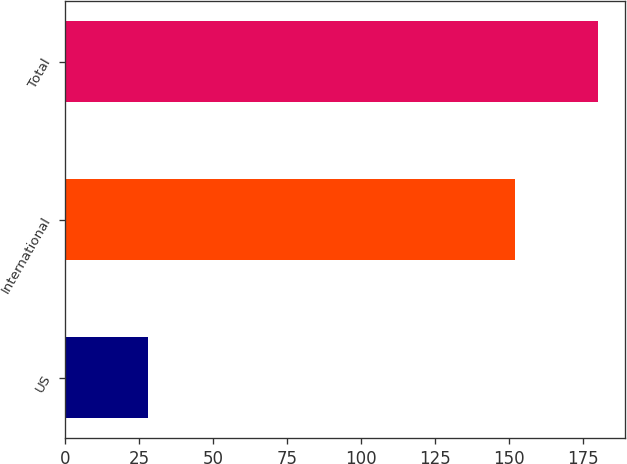Convert chart. <chart><loc_0><loc_0><loc_500><loc_500><bar_chart><fcel>US<fcel>International<fcel>Total<nl><fcel>28<fcel>152<fcel>180<nl></chart> 